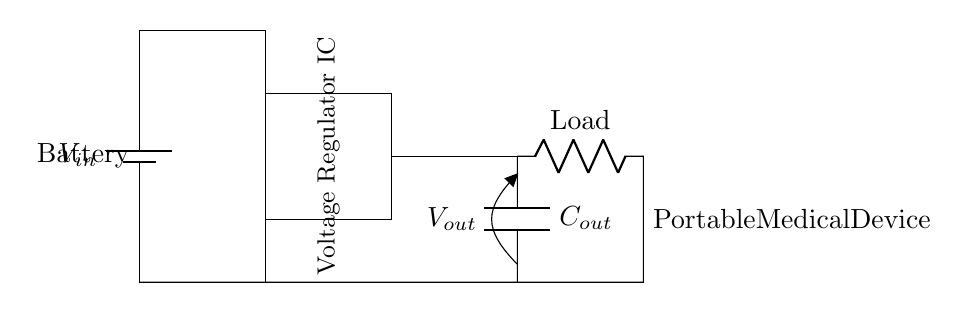What is the input voltage source in the circuit? The input voltage source is the battery labeled as V_in, which provides power to the circuit.
Answer: V_in What is the output voltage from the voltage regulator? The output voltage is labeled as V_out, which is the regulated voltage delivered to the load from the voltage regulator.
Answer: V_out What type of component is used for filtering the output? The component used for filtering is a capacitor, specifically labeled as C_out, which smooths the output voltage from the regulator.
Answer: Capacitor How many main components are shown in the circuit diagram? The main components consist of a battery, a voltage regulator IC, an output capacitor, and a load resistor, totaling four significant parts.
Answer: Four What is the purpose of the voltage regulator IC in this circuit? The purpose of the voltage regulator IC is to maintain a steady output voltage sufficient for powering the medical device regardless of fluctuations in the input voltage from the battery.
Answer: To regulate voltage What is connected to the output of the voltage regulator? The output of the voltage regulator is connected to a load resistor, which represents the portable medical device needing power.
Answer: Load resistor What type of circuit is this diagram primarily representing? This diagram primarily represents a voltage regulator circuit designed for power management in portable medical devices, focusing on stable output from varying input sources.
Answer: Voltage regulator circuit 